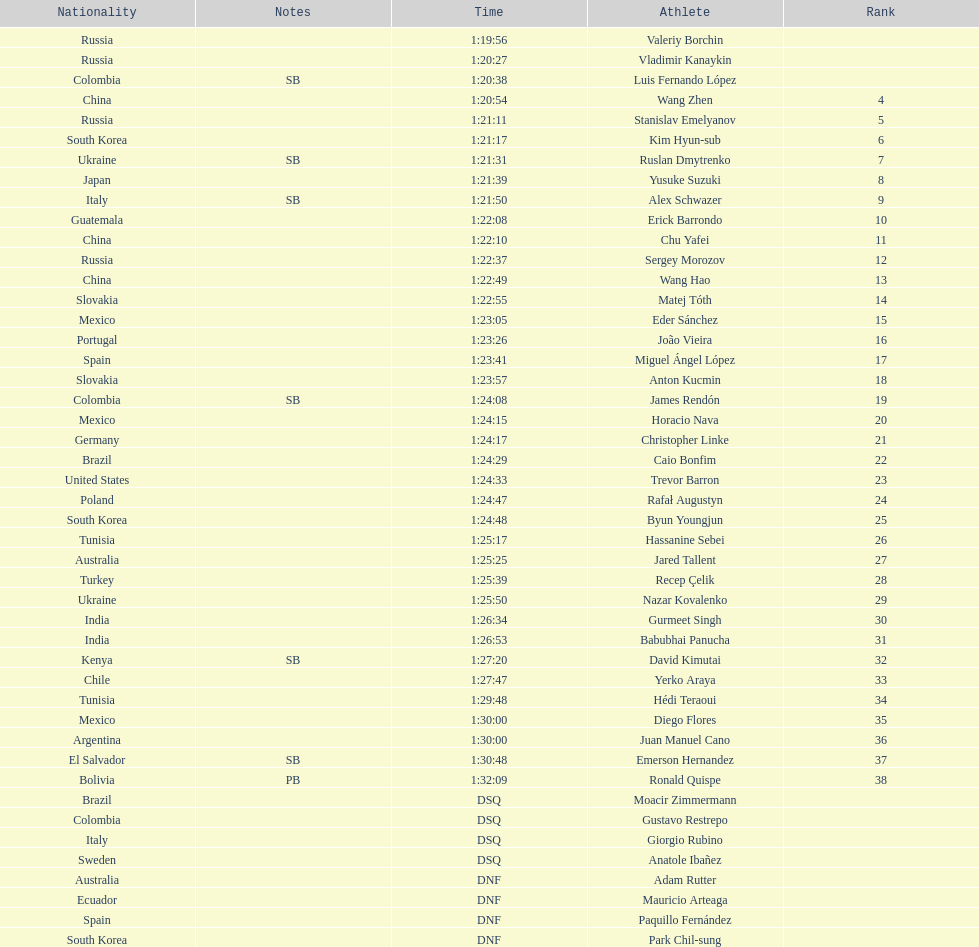Can you parse all the data within this table? {'header': ['Nationality', 'Notes', 'Time', 'Athlete', 'Rank'], 'rows': [['Russia', '', '1:19:56', 'Valeriy Borchin', ''], ['Russia', '', '1:20:27', 'Vladimir Kanaykin', ''], ['Colombia', 'SB', '1:20:38', 'Luis Fernando López', ''], ['China', '', '1:20:54', 'Wang Zhen', '4'], ['Russia', '', '1:21:11', 'Stanislav Emelyanov', '5'], ['South Korea', '', '1:21:17', 'Kim Hyun-sub', '6'], ['Ukraine', 'SB', '1:21:31', 'Ruslan Dmytrenko', '7'], ['Japan', '', '1:21:39', 'Yusuke Suzuki', '8'], ['Italy', 'SB', '1:21:50', 'Alex Schwazer', '9'], ['Guatemala', '', '1:22:08', 'Erick Barrondo', '10'], ['China', '', '1:22:10', 'Chu Yafei', '11'], ['Russia', '', '1:22:37', 'Sergey Morozov', '12'], ['China', '', '1:22:49', 'Wang Hao', '13'], ['Slovakia', '', '1:22:55', 'Matej Tóth', '14'], ['Mexico', '', '1:23:05', 'Eder Sánchez', '15'], ['Portugal', '', '1:23:26', 'João Vieira', '16'], ['Spain', '', '1:23:41', 'Miguel Ángel López', '17'], ['Slovakia', '', '1:23:57', 'Anton Kucmin', '18'], ['Colombia', 'SB', '1:24:08', 'James Rendón', '19'], ['Mexico', '', '1:24:15', 'Horacio Nava', '20'], ['Germany', '', '1:24:17', 'Christopher Linke', '21'], ['Brazil', '', '1:24:29', 'Caio Bonfim', '22'], ['United States', '', '1:24:33', 'Trevor Barron', '23'], ['Poland', '', '1:24:47', 'Rafał Augustyn', '24'], ['South Korea', '', '1:24:48', 'Byun Youngjun', '25'], ['Tunisia', '', '1:25:17', 'Hassanine Sebei', '26'], ['Australia', '', '1:25:25', 'Jared Tallent', '27'], ['Turkey', '', '1:25:39', 'Recep Çelik', '28'], ['Ukraine', '', '1:25:50', 'Nazar Kovalenko', '29'], ['India', '', '1:26:34', 'Gurmeet Singh', '30'], ['India', '', '1:26:53', 'Babubhai Panucha', '31'], ['Kenya', 'SB', '1:27:20', 'David Kimutai', '32'], ['Chile', '', '1:27:47', 'Yerko Araya', '33'], ['Tunisia', '', '1:29:48', 'Hédi Teraoui', '34'], ['Mexico', '', '1:30:00', 'Diego Flores', '35'], ['Argentina', '', '1:30:00', 'Juan Manuel Cano', '36'], ['El Salvador', 'SB', '1:30:48', 'Emerson Hernandez', '37'], ['Bolivia', 'PB', '1:32:09', 'Ronald Quispe', '38'], ['Brazil', '', 'DSQ', 'Moacir Zimmermann', ''], ['Colombia', '', 'DSQ', 'Gustavo Restrepo', ''], ['Italy', '', 'DSQ', 'Giorgio Rubino', ''], ['Sweden', '', 'DSQ', 'Anatole Ibañez', ''], ['Australia', '', 'DNF', 'Adam Rutter', ''], ['Ecuador', '', 'DNF', 'Mauricio Arteaga', ''], ['Spain', '', 'DNF', 'Paquillo Fernández', ''], ['South Korea', '', 'DNF', 'Park Chil-sung', '']]} How many competitors were from russia? 4. 